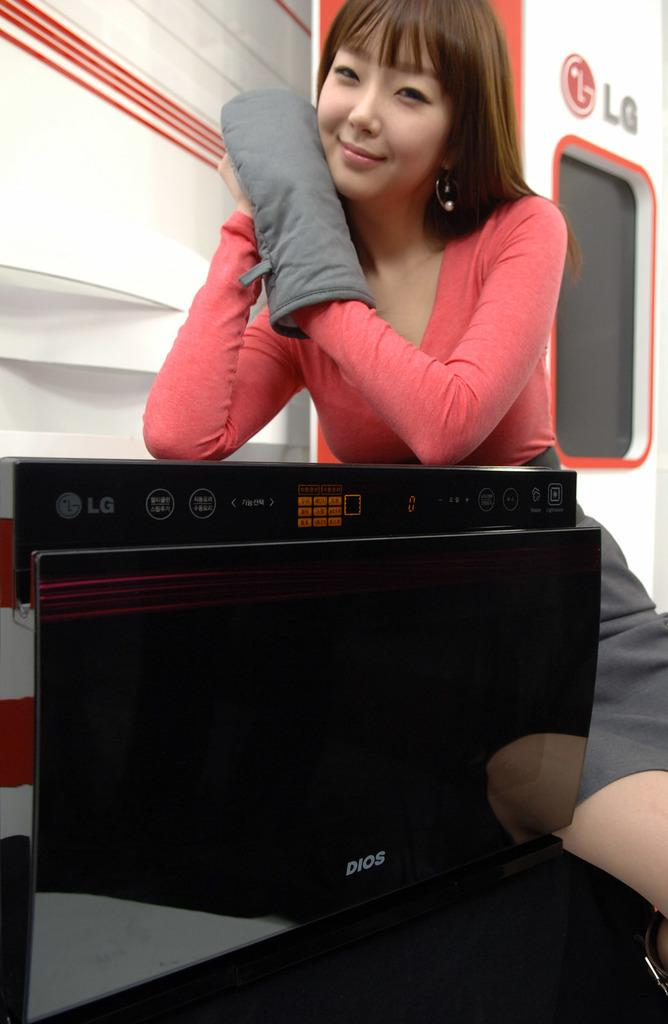<image>
Provide a brief description of the given image. A woman posing with an oven mitt next to a black LG oven. 